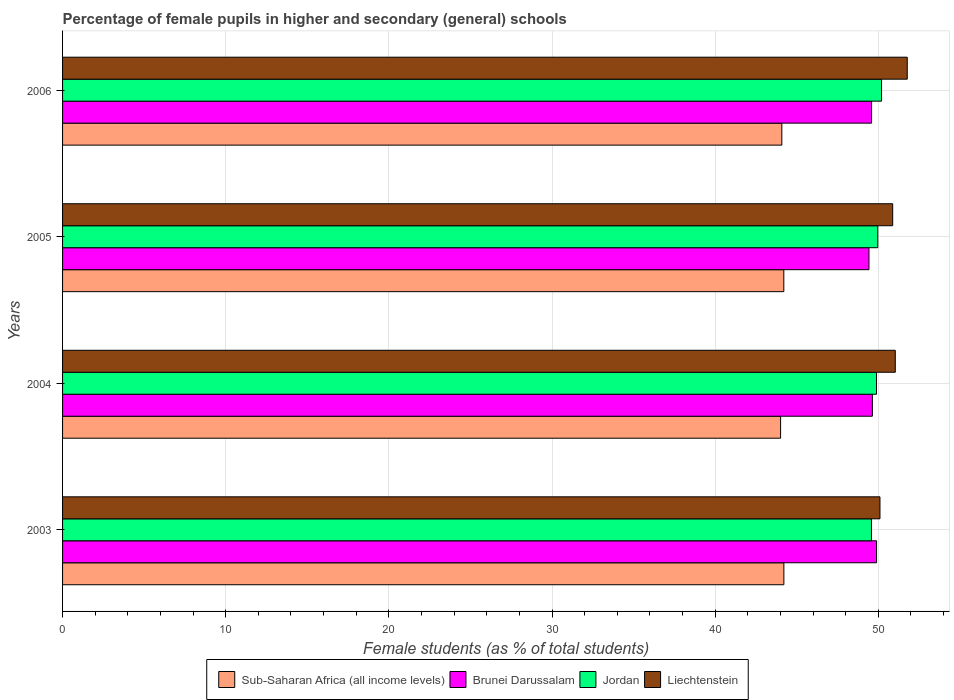How many groups of bars are there?
Offer a terse response. 4. Are the number of bars on each tick of the Y-axis equal?
Make the answer very short. Yes. In how many cases, is the number of bars for a given year not equal to the number of legend labels?
Offer a terse response. 0. What is the percentage of female pupils in higher and secondary schools in Brunei Darussalam in 2005?
Provide a short and direct response. 49.43. Across all years, what is the maximum percentage of female pupils in higher and secondary schools in Sub-Saharan Africa (all income levels)?
Keep it short and to the point. 44.21. Across all years, what is the minimum percentage of female pupils in higher and secondary schools in Brunei Darussalam?
Ensure brevity in your answer.  49.43. What is the total percentage of female pupils in higher and secondary schools in Jordan in the graph?
Provide a short and direct response. 199.62. What is the difference between the percentage of female pupils in higher and secondary schools in Sub-Saharan Africa (all income levels) in 2004 and that in 2005?
Offer a terse response. -0.2. What is the difference between the percentage of female pupils in higher and secondary schools in Brunei Darussalam in 2004 and the percentage of female pupils in higher and secondary schools in Liechtenstein in 2006?
Your answer should be very brief. -2.14. What is the average percentage of female pupils in higher and secondary schools in Sub-Saharan Africa (all income levels) per year?
Keep it short and to the point. 44.13. In the year 2003, what is the difference between the percentage of female pupils in higher and secondary schools in Sub-Saharan Africa (all income levels) and percentage of female pupils in higher and secondary schools in Jordan?
Give a very brief answer. -5.37. In how many years, is the percentage of female pupils in higher and secondary schools in Brunei Darussalam greater than 36 %?
Offer a terse response. 4. What is the ratio of the percentage of female pupils in higher and secondary schools in Sub-Saharan Africa (all income levels) in 2003 to that in 2005?
Make the answer very short. 1. What is the difference between the highest and the second highest percentage of female pupils in higher and secondary schools in Liechtenstein?
Make the answer very short. 0.73. What is the difference between the highest and the lowest percentage of female pupils in higher and secondary schools in Sub-Saharan Africa (all income levels)?
Offer a terse response. 0.2. In how many years, is the percentage of female pupils in higher and secondary schools in Brunei Darussalam greater than the average percentage of female pupils in higher and secondary schools in Brunei Darussalam taken over all years?
Your response must be concise. 2. Is it the case that in every year, the sum of the percentage of female pupils in higher and secondary schools in Brunei Darussalam and percentage of female pupils in higher and secondary schools in Jordan is greater than the sum of percentage of female pupils in higher and secondary schools in Sub-Saharan Africa (all income levels) and percentage of female pupils in higher and secondary schools in Liechtenstein?
Make the answer very short. No. What does the 2nd bar from the top in 2004 represents?
Ensure brevity in your answer.  Jordan. What does the 2nd bar from the bottom in 2003 represents?
Your answer should be very brief. Brunei Darussalam. Is it the case that in every year, the sum of the percentage of female pupils in higher and secondary schools in Jordan and percentage of female pupils in higher and secondary schools in Liechtenstein is greater than the percentage of female pupils in higher and secondary schools in Brunei Darussalam?
Your response must be concise. Yes. Are all the bars in the graph horizontal?
Provide a short and direct response. Yes. What is the difference between two consecutive major ticks on the X-axis?
Make the answer very short. 10. How many legend labels are there?
Ensure brevity in your answer.  4. What is the title of the graph?
Ensure brevity in your answer.  Percentage of female pupils in higher and secondary (general) schools. Does "Vanuatu" appear as one of the legend labels in the graph?
Ensure brevity in your answer.  No. What is the label or title of the X-axis?
Provide a succinct answer. Female students (as % of total students). What is the label or title of the Y-axis?
Make the answer very short. Years. What is the Female students (as % of total students) of Sub-Saharan Africa (all income levels) in 2003?
Your answer should be very brief. 44.21. What is the Female students (as % of total students) of Brunei Darussalam in 2003?
Ensure brevity in your answer.  49.89. What is the Female students (as % of total students) of Jordan in 2003?
Offer a very short reply. 49.58. What is the Female students (as % of total students) in Liechtenstein in 2003?
Provide a short and direct response. 50.1. What is the Female students (as % of total students) in Sub-Saharan Africa (all income levels) in 2004?
Your answer should be compact. 44.01. What is the Female students (as % of total students) in Brunei Darussalam in 2004?
Offer a very short reply. 49.63. What is the Female students (as % of total students) in Jordan in 2004?
Make the answer very short. 49.89. What is the Female students (as % of total students) of Liechtenstein in 2004?
Your answer should be very brief. 51.04. What is the Female students (as % of total students) in Sub-Saharan Africa (all income levels) in 2005?
Make the answer very short. 44.21. What is the Female students (as % of total students) in Brunei Darussalam in 2005?
Your answer should be very brief. 49.43. What is the Female students (as % of total students) in Jordan in 2005?
Your answer should be compact. 49.96. What is the Female students (as % of total students) in Liechtenstein in 2005?
Your response must be concise. 50.88. What is the Female students (as % of total students) of Sub-Saharan Africa (all income levels) in 2006?
Provide a succinct answer. 44.08. What is the Female students (as % of total students) in Brunei Darussalam in 2006?
Ensure brevity in your answer.  49.58. What is the Female students (as % of total students) of Jordan in 2006?
Offer a very short reply. 50.2. What is the Female students (as % of total students) in Liechtenstein in 2006?
Ensure brevity in your answer.  51.77. Across all years, what is the maximum Female students (as % of total students) of Sub-Saharan Africa (all income levels)?
Offer a terse response. 44.21. Across all years, what is the maximum Female students (as % of total students) of Brunei Darussalam?
Provide a short and direct response. 49.89. Across all years, what is the maximum Female students (as % of total students) in Jordan?
Your answer should be compact. 50.2. Across all years, what is the maximum Female students (as % of total students) in Liechtenstein?
Keep it short and to the point. 51.77. Across all years, what is the minimum Female students (as % of total students) in Sub-Saharan Africa (all income levels)?
Your answer should be compact. 44.01. Across all years, what is the minimum Female students (as % of total students) of Brunei Darussalam?
Offer a terse response. 49.43. Across all years, what is the minimum Female students (as % of total students) in Jordan?
Offer a very short reply. 49.58. Across all years, what is the minimum Female students (as % of total students) in Liechtenstein?
Keep it short and to the point. 50.1. What is the total Female students (as % of total students) of Sub-Saharan Africa (all income levels) in the graph?
Provide a short and direct response. 176.51. What is the total Female students (as % of total students) in Brunei Darussalam in the graph?
Make the answer very short. 198.53. What is the total Female students (as % of total students) of Jordan in the graph?
Provide a short and direct response. 199.62. What is the total Female students (as % of total students) in Liechtenstein in the graph?
Keep it short and to the point. 203.79. What is the difference between the Female students (as % of total students) in Sub-Saharan Africa (all income levels) in 2003 and that in 2004?
Provide a succinct answer. 0.2. What is the difference between the Female students (as % of total students) of Brunei Darussalam in 2003 and that in 2004?
Your response must be concise. 0.26. What is the difference between the Female students (as % of total students) in Jordan in 2003 and that in 2004?
Make the answer very short. -0.31. What is the difference between the Female students (as % of total students) of Liechtenstein in 2003 and that in 2004?
Make the answer very short. -0.94. What is the difference between the Female students (as % of total students) in Sub-Saharan Africa (all income levels) in 2003 and that in 2005?
Keep it short and to the point. 0. What is the difference between the Female students (as % of total students) of Brunei Darussalam in 2003 and that in 2005?
Keep it short and to the point. 0.46. What is the difference between the Female students (as % of total students) of Jordan in 2003 and that in 2005?
Make the answer very short. -0.39. What is the difference between the Female students (as % of total students) in Liechtenstein in 2003 and that in 2005?
Ensure brevity in your answer.  -0.78. What is the difference between the Female students (as % of total students) in Sub-Saharan Africa (all income levels) in 2003 and that in 2006?
Make the answer very short. 0.13. What is the difference between the Female students (as % of total students) in Brunei Darussalam in 2003 and that in 2006?
Offer a very short reply. 0.31. What is the difference between the Female students (as % of total students) of Jordan in 2003 and that in 2006?
Offer a terse response. -0.62. What is the difference between the Female students (as % of total students) in Liechtenstein in 2003 and that in 2006?
Your answer should be very brief. -1.67. What is the difference between the Female students (as % of total students) of Sub-Saharan Africa (all income levels) in 2004 and that in 2005?
Your response must be concise. -0.2. What is the difference between the Female students (as % of total students) in Brunei Darussalam in 2004 and that in 2005?
Your answer should be compact. 0.21. What is the difference between the Female students (as % of total students) of Jordan in 2004 and that in 2005?
Make the answer very short. -0.08. What is the difference between the Female students (as % of total students) in Liechtenstein in 2004 and that in 2005?
Offer a very short reply. 0.16. What is the difference between the Female students (as % of total students) in Sub-Saharan Africa (all income levels) in 2004 and that in 2006?
Your answer should be compact. -0.08. What is the difference between the Female students (as % of total students) of Brunei Darussalam in 2004 and that in 2006?
Offer a terse response. 0.05. What is the difference between the Female students (as % of total students) in Jordan in 2004 and that in 2006?
Give a very brief answer. -0.31. What is the difference between the Female students (as % of total students) of Liechtenstein in 2004 and that in 2006?
Provide a short and direct response. -0.73. What is the difference between the Female students (as % of total students) in Sub-Saharan Africa (all income levels) in 2005 and that in 2006?
Your answer should be very brief. 0.12. What is the difference between the Female students (as % of total students) of Brunei Darussalam in 2005 and that in 2006?
Ensure brevity in your answer.  -0.16. What is the difference between the Female students (as % of total students) of Jordan in 2005 and that in 2006?
Make the answer very short. -0.23. What is the difference between the Female students (as % of total students) of Liechtenstein in 2005 and that in 2006?
Make the answer very short. -0.89. What is the difference between the Female students (as % of total students) in Sub-Saharan Africa (all income levels) in 2003 and the Female students (as % of total students) in Brunei Darussalam in 2004?
Provide a succinct answer. -5.43. What is the difference between the Female students (as % of total students) of Sub-Saharan Africa (all income levels) in 2003 and the Female students (as % of total students) of Jordan in 2004?
Offer a terse response. -5.68. What is the difference between the Female students (as % of total students) in Sub-Saharan Africa (all income levels) in 2003 and the Female students (as % of total students) in Liechtenstein in 2004?
Ensure brevity in your answer.  -6.83. What is the difference between the Female students (as % of total students) in Brunei Darussalam in 2003 and the Female students (as % of total students) in Jordan in 2004?
Provide a short and direct response. 0. What is the difference between the Female students (as % of total students) in Brunei Darussalam in 2003 and the Female students (as % of total students) in Liechtenstein in 2004?
Make the answer very short. -1.15. What is the difference between the Female students (as % of total students) in Jordan in 2003 and the Female students (as % of total students) in Liechtenstein in 2004?
Keep it short and to the point. -1.46. What is the difference between the Female students (as % of total students) in Sub-Saharan Africa (all income levels) in 2003 and the Female students (as % of total students) in Brunei Darussalam in 2005?
Make the answer very short. -5.22. What is the difference between the Female students (as % of total students) of Sub-Saharan Africa (all income levels) in 2003 and the Female students (as % of total students) of Jordan in 2005?
Make the answer very short. -5.75. What is the difference between the Female students (as % of total students) in Sub-Saharan Africa (all income levels) in 2003 and the Female students (as % of total students) in Liechtenstein in 2005?
Provide a succinct answer. -6.67. What is the difference between the Female students (as % of total students) in Brunei Darussalam in 2003 and the Female students (as % of total students) in Jordan in 2005?
Keep it short and to the point. -0.07. What is the difference between the Female students (as % of total students) in Brunei Darussalam in 2003 and the Female students (as % of total students) in Liechtenstein in 2005?
Your response must be concise. -0.99. What is the difference between the Female students (as % of total students) in Jordan in 2003 and the Female students (as % of total students) in Liechtenstein in 2005?
Offer a terse response. -1.3. What is the difference between the Female students (as % of total students) of Sub-Saharan Africa (all income levels) in 2003 and the Female students (as % of total students) of Brunei Darussalam in 2006?
Your response must be concise. -5.38. What is the difference between the Female students (as % of total students) of Sub-Saharan Africa (all income levels) in 2003 and the Female students (as % of total students) of Jordan in 2006?
Offer a terse response. -5.99. What is the difference between the Female students (as % of total students) in Sub-Saharan Africa (all income levels) in 2003 and the Female students (as % of total students) in Liechtenstein in 2006?
Your response must be concise. -7.56. What is the difference between the Female students (as % of total students) in Brunei Darussalam in 2003 and the Female students (as % of total students) in Jordan in 2006?
Your response must be concise. -0.31. What is the difference between the Female students (as % of total students) of Brunei Darussalam in 2003 and the Female students (as % of total students) of Liechtenstein in 2006?
Provide a short and direct response. -1.88. What is the difference between the Female students (as % of total students) in Jordan in 2003 and the Female students (as % of total students) in Liechtenstein in 2006?
Offer a terse response. -2.19. What is the difference between the Female students (as % of total students) of Sub-Saharan Africa (all income levels) in 2004 and the Female students (as % of total students) of Brunei Darussalam in 2005?
Offer a terse response. -5.42. What is the difference between the Female students (as % of total students) of Sub-Saharan Africa (all income levels) in 2004 and the Female students (as % of total students) of Jordan in 2005?
Your response must be concise. -5.96. What is the difference between the Female students (as % of total students) in Sub-Saharan Africa (all income levels) in 2004 and the Female students (as % of total students) in Liechtenstein in 2005?
Give a very brief answer. -6.87. What is the difference between the Female students (as % of total students) of Brunei Darussalam in 2004 and the Female students (as % of total students) of Jordan in 2005?
Make the answer very short. -0.33. What is the difference between the Female students (as % of total students) in Brunei Darussalam in 2004 and the Female students (as % of total students) in Liechtenstein in 2005?
Give a very brief answer. -1.24. What is the difference between the Female students (as % of total students) of Jordan in 2004 and the Female students (as % of total students) of Liechtenstein in 2005?
Offer a terse response. -0.99. What is the difference between the Female students (as % of total students) of Sub-Saharan Africa (all income levels) in 2004 and the Female students (as % of total students) of Brunei Darussalam in 2006?
Ensure brevity in your answer.  -5.58. What is the difference between the Female students (as % of total students) in Sub-Saharan Africa (all income levels) in 2004 and the Female students (as % of total students) in Jordan in 2006?
Your answer should be very brief. -6.19. What is the difference between the Female students (as % of total students) in Sub-Saharan Africa (all income levels) in 2004 and the Female students (as % of total students) in Liechtenstein in 2006?
Make the answer very short. -7.76. What is the difference between the Female students (as % of total students) in Brunei Darussalam in 2004 and the Female students (as % of total students) in Jordan in 2006?
Offer a terse response. -0.56. What is the difference between the Female students (as % of total students) in Brunei Darussalam in 2004 and the Female students (as % of total students) in Liechtenstein in 2006?
Offer a very short reply. -2.14. What is the difference between the Female students (as % of total students) of Jordan in 2004 and the Female students (as % of total students) of Liechtenstein in 2006?
Give a very brief answer. -1.89. What is the difference between the Female students (as % of total students) in Sub-Saharan Africa (all income levels) in 2005 and the Female students (as % of total students) in Brunei Darussalam in 2006?
Your answer should be very brief. -5.38. What is the difference between the Female students (as % of total students) in Sub-Saharan Africa (all income levels) in 2005 and the Female students (as % of total students) in Jordan in 2006?
Give a very brief answer. -5.99. What is the difference between the Female students (as % of total students) in Sub-Saharan Africa (all income levels) in 2005 and the Female students (as % of total students) in Liechtenstein in 2006?
Offer a terse response. -7.57. What is the difference between the Female students (as % of total students) of Brunei Darussalam in 2005 and the Female students (as % of total students) of Jordan in 2006?
Make the answer very short. -0.77. What is the difference between the Female students (as % of total students) of Brunei Darussalam in 2005 and the Female students (as % of total students) of Liechtenstein in 2006?
Provide a succinct answer. -2.35. What is the difference between the Female students (as % of total students) of Jordan in 2005 and the Female students (as % of total students) of Liechtenstein in 2006?
Keep it short and to the point. -1.81. What is the average Female students (as % of total students) of Sub-Saharan Africa (all income levels) per year?
Provide a succinct answer. 44.13. What is the average Female students (as % of total students) of Brunei Darussalam per year?
Keep it short and to the point. 49.63. What is the average Female students (as % of total students) in Jordan per year?
Give a very brief answer. 49.91. What is the average Female students (as % of total students) in Liechtenstein per year?
Give a very brief answer. 50.95. In the year 2003, what is the difference between the Female students (as % of total students) in Sub-Saharan Africa (all income levels) and Female students (as % of total students) in Brunei Darussalam?
Your answer should be compact. -5.68. In the year 2003, what is the difference between the Female students (as % of total students) of Sub-Saharan Africa (all income levels) and Female students (as % of total students) of Jordan?
Provide a succinct answer. -5.37. In the year 2003, what is the difference between the Female students (as % of total students) in Sub-Saharan Africa (all income levels) and Female students (as % of total students) in Liechtenstein?
Provide a succinct answer. -5.89. In the year 2003, what is the difference between the Female students (as % of total students) in Brunei Darussalam and Female students (as % of total students) in Jordan?
Make the answer very short. 0.31. In the year 2003, what is the difference between the Female students (as % of total students) of Brunei Darussalam and Female students (as % of total students) of Liechtenstein?
Ensure brevity in your answer.  -0.21. In the year 2003, what is the difference between the Female students (as % of total students) of Jordan and Female students (as % of total students) of Liechtenstein?
Offer a terse response. -0.52. In the year 2004, what is the difference between the Female students (as % of total students) of Sub-Saharan Africa (all income levels) and Female students (as % of total students) of Brunei Darussalam?
Provide a succinct answer. -5.63. In the year 2004, what is the difference between the Female students (as % of total students) of Sub-Saharan Africa (all income levels) and Female students (as % of total students) of Jordan?
Offer a very short reply. -5.88. In the year 2004, what is the difference between the Female students (as % of total students) of Sub-Saharan Africa (all income levels) and Female students (as % of total students) of Liechtenstein?
Your answer should be compact. -7.03. In the year 2004, what is the difference between the Female students (as % of total students) in Brunei Darussalam and Female students (as % of total students) in Jordan?
Your answer should be very brief. -0.25. In the year 2004, what is the difference between the Female students (as % of total students) of Brunei Darussalam and Female students (as % of total students) of Liechtenstein?
Offer a terse response. -1.4. In the year 2004, what is the difference between the Female students (as % of total students) in Jordan and Female students (as % of total students) in Liechtenstein?
Provide a short and direct response. -1.15. In the year 2005, what is the difference between the Female students (as % of total students) in Sub-Saharan Africa (all income levels) and Female students (as % of total students) in Brunei Darussalam?
Your answer should be compact. -5.22. In the year 2005, what is the difference between the Female students (as % of total students) in Sub-Saharan Africa (all income levels) and Female students (as % of total students) in Jordan?
Offer a terse response. -5.76. In the year 2005, what is the difference between the Female students (as % of total students) in Sub-Saharan Africa (all income levels) and Female students (as % of total students) in Liechtenstein?
Provide a succinct answer. -6.67. In the year 2005, what is the difference between the Female students (as % of total students) in Brunei Darussalam and Female students (as % of total students) in Jordan?
Offer a very short reply. -0.54. In the year 2005, what is the difference between the Female students (as % of total students) in Brunei Darussalam and Female students (as % of total students) in Liechtenstein?
Your answer should be compact. -1.45. In the year 2005, what is the difference between the Female students (as % of total students) of Jordan and Female students (as % of total students) of Liechtenstein?
Make the answer very short. -0.92. In the year 2006, what is the difference between the Female students (as % of total students) of Sub-Saharan Africa (all income levels) and Female students (as % of total students) of Brunei Darussalam?
Ensure brevity in your answer.  -5.5. In the year 2006, what is the difference between the Female students (as % of total students) in Sub-Saharan Africa (all income levels) and Female students (as % of total students) in Jordan?
Ensure brevity in your answer.  -6.11. In the year 2006, what is the difference between the Female students (as % of total students) of Sub-Saharan Africa (all income levels) and Female students (as % of total students) of Liechtenstein?
Your answer should be very brief. -7.69. In the year 2006, what is the difference between the Female students (as % of total students) in Brunei Darussalam and Female students (as % of total students) in Jordan?
Ensure brevity in your answer.  -0.61. In the year 2006, what is the difference between the Female students (as % of total students) of Brunei Darussalam and Female students (as % of total students) of Liechtenstein?
Your response must be concise. -2.19. In the year 2006, what is the difference between the Female students (as % of total students) in Jordan and Female students (as % of total students) in Liechtenstein?
Keep it short and to the point. -1.58. What is the ratio of the Female students (as % of total students) in Sub-Saharan Africa (all income levels) in 2003 to that in 2004?
Give a very brief answer. 1. What is the ratio of the Female students (as % of total students) in Brunei Darussalam in 2003 to that in 2004?
Provide a short and direct response. 1.01. What is the ratio of the Female students (as % of total students) in Liechtenstein in 2003 to that in 2004?
Make the answer very short. 0.98. What is the ratio of the Female students (as % of total students) in Sub-Saharan Africa (all income levels) in 2003 to that in 2005?
Keep it short and to the point. 1. What is the ratio of the Female students (as % of total students) of Brunei Darussalam in 2003 to that in 2005?
Keep it short and to the point. 1.01. What is the ratio of the Female students (as % of total students) in Jordan in 2003 to that in 2005?
Give a very brief answer. 0.99. What is the ratio of the Female students (as % of total students) of Liechtenstein in 2003 to that in 2005?
Keep it short and to the point. 0.98. What is the ratio of the Female students (as % of total students) of Brunei Darussalam in 2003 to that in 2006?
Offer a very short reply. 1.01. What is the ratio of the Female students (as % of total students) of Jordan in 2003 to that in 2006?
Offer a very short reply. 0.99. What is the ratio of the Female students (as % of total students) of Liechtenstein in 2003 to that in 2006?
Your response must be concise. 0.97. What is the ratio of the Female students (as % of total students) in Sub-Saharan Africa (all income levels) in 2004 to that in 2005?
Ensure brevity in your answer.  1. What is the ratio of the Female students (as % of total students) in Jordan in 2004 to that in 2006?
Offer a very short reply. 0.99. What is the ratio of the Female students (as % of total students) of Liechtenstein in 2004 to that in 2006?
Keep it short and to the point. 0.99. What is the ratio of the Female students (as % of total students) in Sub-Saharan Africa (all income levels) in 2005 to that in 2006?
Your answer should be very brief. 1. What is the ratio of the Female students (as % of total students) of Jordan in 2005 to that in 2006?
Your answer should be very brief. 1. What is the ratio of the Female students (as % of total students) of Liechtenstein in 2005 to that in 2006?
Keep it short and to the point. 0.98. What is the difference between the highest and the second highest Female students (as % of total students) in Sub-Saharan Africa (all income levels)?
Provide a succinct answer. 0. What is the difference between the highest and the second highest Female students (as % of total students) of Brunei Darussalam?
Your answer should be very brief. 0.26. What is the difference between the highest and the second highest Female students (as % of total students) of Jordan?
Offer a very short reply. 0.23. What is the difference between the highest and the second highest Female students (as % of total students) in Liechtenstein?
Provide a succinct answer. 0.73. What is the difference between the highest and the lowest Female students (as % of total students) in Sub-Saharan Africa (all income levels)?
Make the answer very short. 0.2. What is the difference between the highest and the lowest Female students (as % of total students) of Brunei Darussalam?
Your answer should be very brief. 0.46. What is the difference between the highest and the lowest Female students (as % of total students) in Jordan?
Provide a short and direct response. 0.62. What is the difference between the highest and the lowest Female students (as % of total students) in Liechtenstein?
Ensure brevity in your answer.  1.67. 